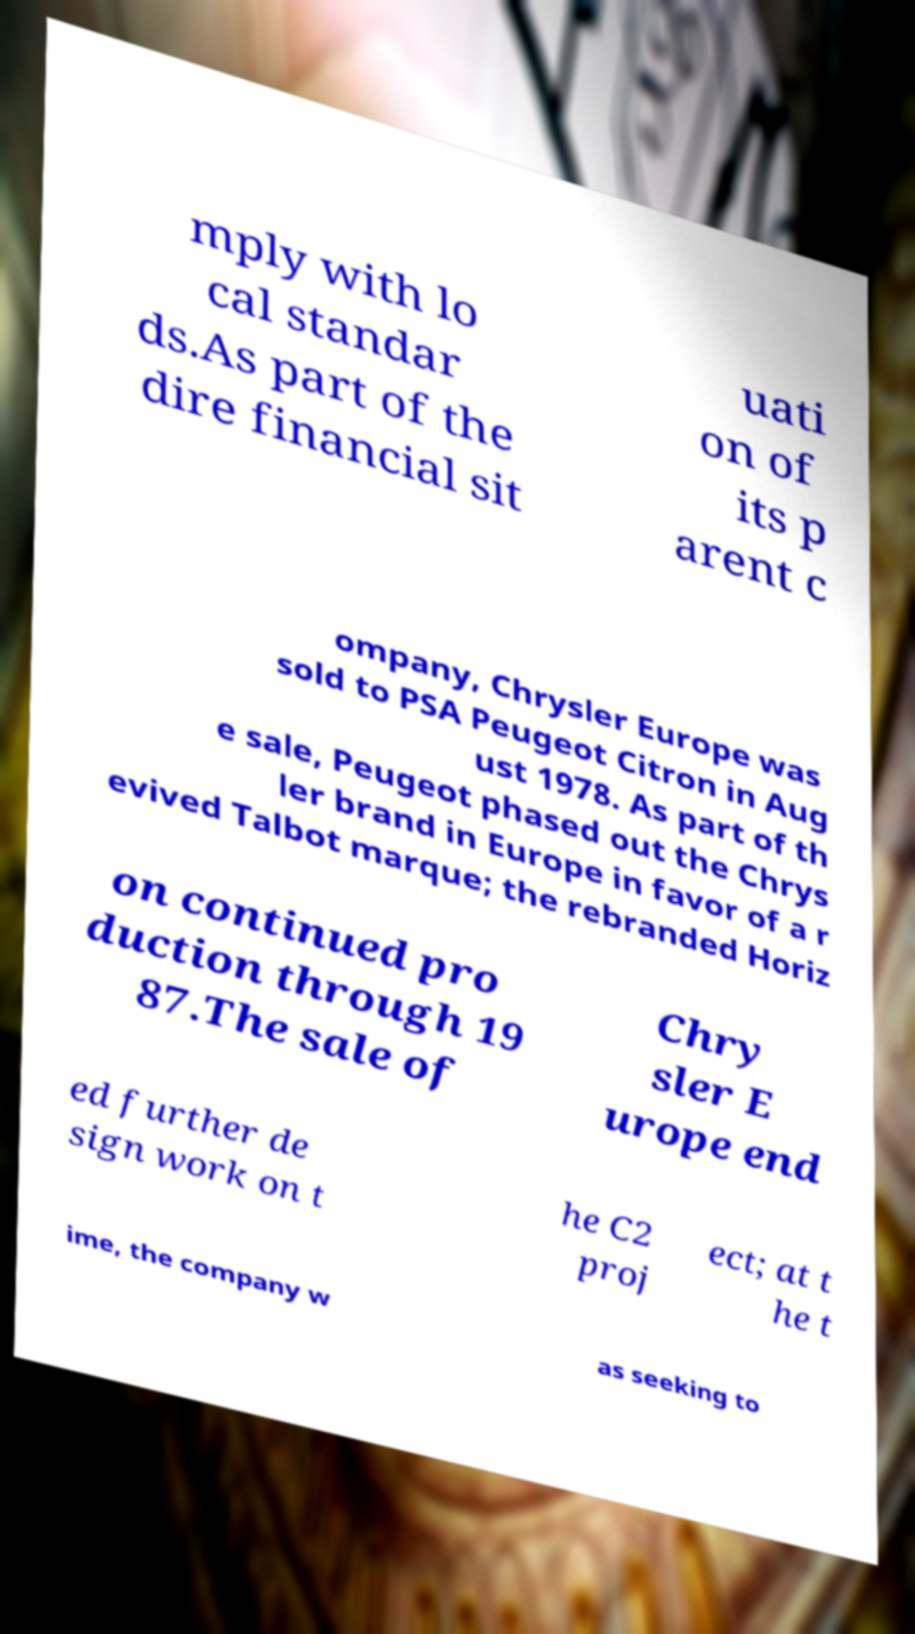For documentation purposes, I need the text within this image transcribed. Could you provide that? mply with lo cal standar ds.As part of the dire financial sit uati on of its p arent c ompany, Chrysler Europe was sold to PSA Peugeot Citron in Aug ust 1978. As part of th e sale, Peugeot phased out the Chrys ler brand in Europe in favor of a r evived Talbot marque; the rebranded Horiz on continued pro duction through 19 87.The sale of Chry sler E urope end ed further de sign work on t he C2 proj ect; at t he t ime, the company w as seeking to 